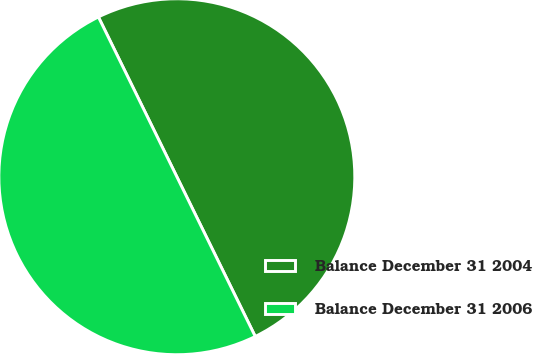Convert chart. <chart><loc_0><loc_0><loc_500><loc_500><pie_chart><fcel>Balance December 31 2004<fcel>Balance December 31 2006<nl><fcel>50.0%<fcel>50.0%<nl></chart> 